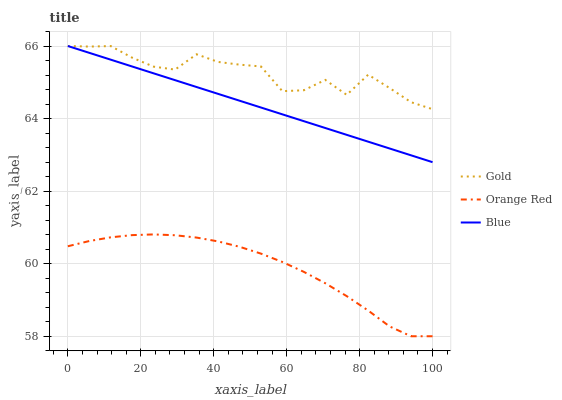Does Orange Red have the minimum area under the curve?
Answer yes or no. Yes. Does Gold have the maximum area under the curve?
Answer yes or no. Yes. Does Gold have the minimum area under the curve?
Answer yes or no. No. Does Orange Red have the maximum area under the curve?
Answer yes or no. No. Is Blue the smoothest?
Answer yes or no. Yes. Is Gold the roughest?
Answer yes or no. Yes. Is Orange Red the smoothest?
Answer yes or no. No. Is Orange Red the roughest?
Answer yes or no. No. Does Orange Red have the lowest value?
Answer yes or no. Yes. Does Gold have the lowest value?
Answer yes or no. No. Does Gold have the highest value?
Answer yes or no. Yes. Does Orange Red have the highest value?
Answer yes or no. No. Is Orange Red less than Gold?
Answer yes or no. Yes. Is Blue greater than Orange Red?
Answer yes or no. Yes. Does Blue intersect Gold?
Answer yes or no. Yes. Is Blue less than Gold?
Answer yes or no. No. Is Blue greater than Gold?
Answer yes or no. No. Does Orange Red intersect Gold?
Answer yes or no. No. 